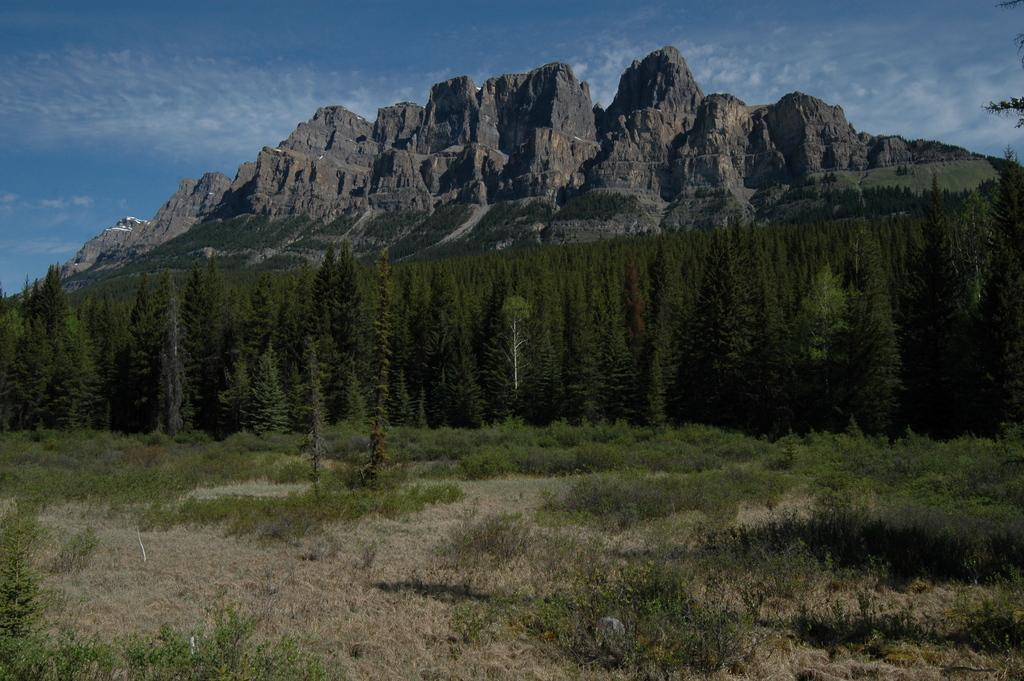What type of ground covering can be seen in the image? The ground in the image is covered with grass. What else is present on the ground in the image? There are dry plants on the ground. What can be seen in the background of the image? There are trees and rock hills visible in the background. What is visible at the top of the image? The sky is clear and visible at the top of the image. What type of calculator can be seen on the grass in the image? There is no calculator present in the image; it features grass, dry plants, trees, rock hills, and a clear sky. How long does the rest period last for the trees in the image? There is no indication of a rest period for the trees in the image; they are simply visible in the background. 